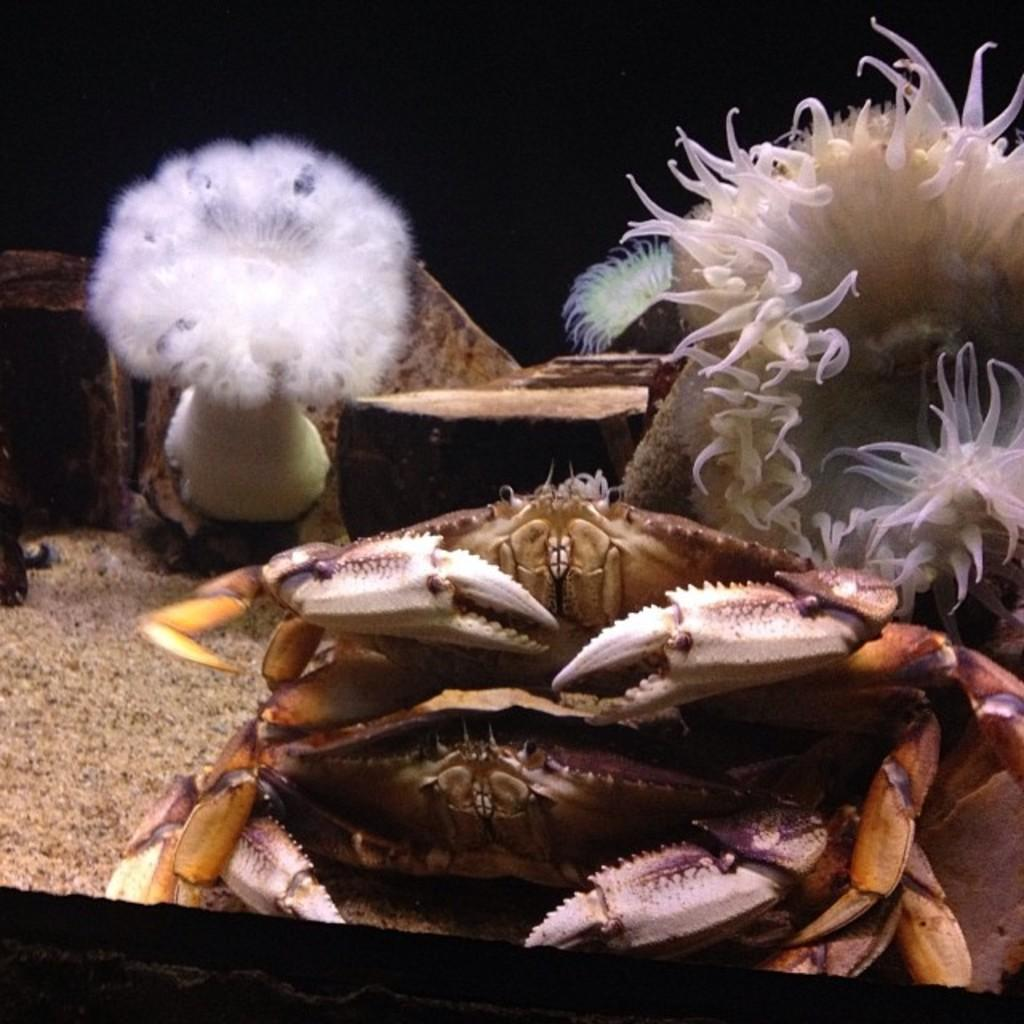What type of animals can be seen in the image? There are crabs in the image. What else can be seen in the image besides the crabs? There are other unspecified things in the image. What is the color of the background in the image? The background of the image is dark. How many eyes does the soap have in the image? There is no soap present in the image, so it is not possible to determine the number of eyes it might have. 